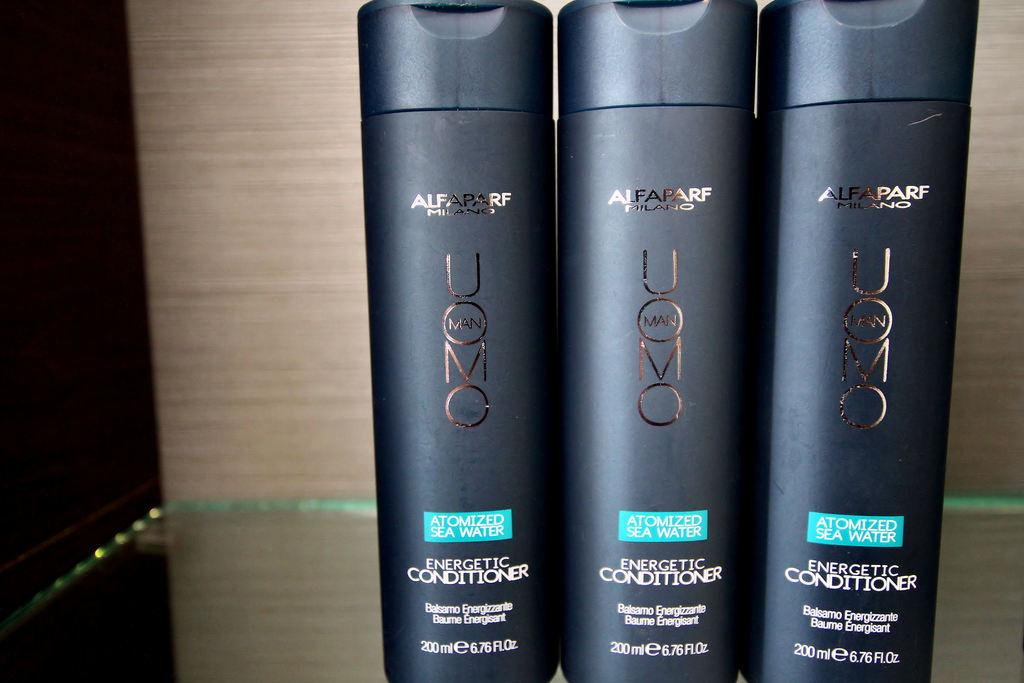Provide a one-sentence caption for the provided image. Three containers of Energetic Conditioner are lined up next to each other. 